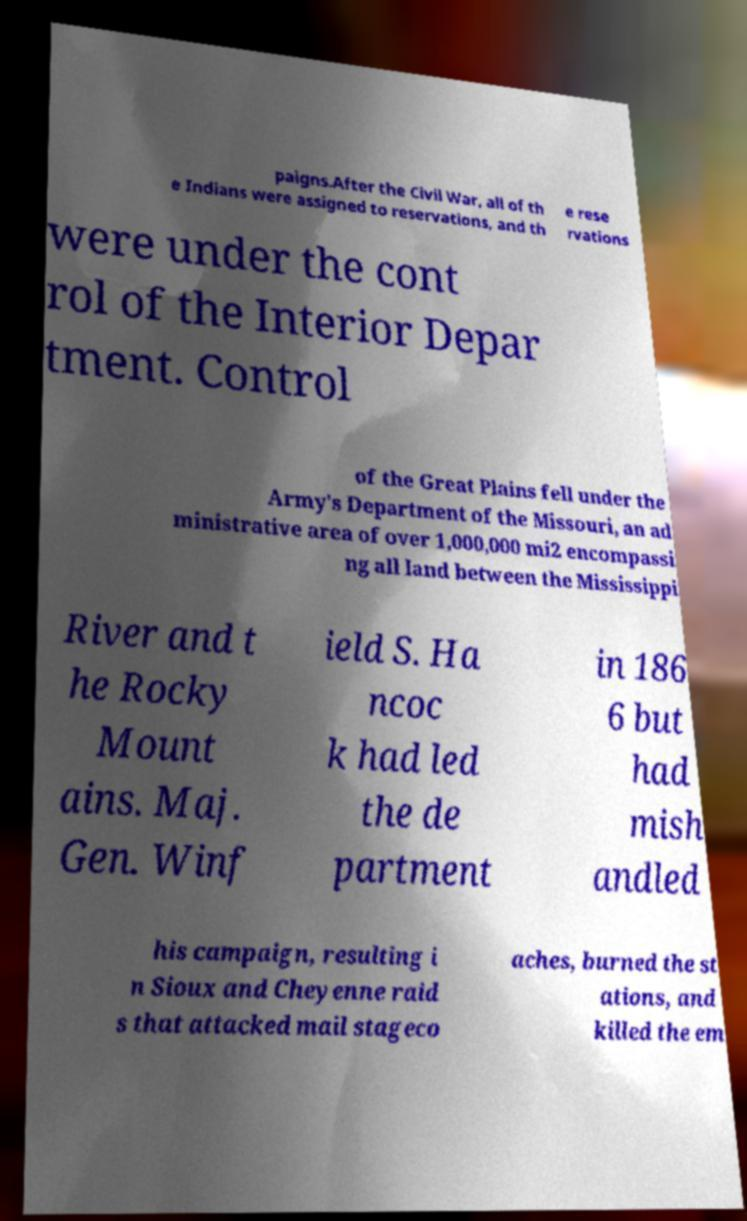There's text embedded in this image that I need extracted. Can you transcribe it verbatim? paigns.After the Civil War, all of th e Indians were assigned to reservations, and th e rese rvations were under the cont rol of the Interior Depar tment. Control of the Great Plains fell under the Army's Department of the Missouri, an ad ministrative area of over 1,000,000 mi2 encompassi ng all land between the Mississippi River and t he Rocky Mount ains. Maj. Gen. Winf ield S. Ha ncoc k had led the de partment in 186 6 but had mish andled his campaign, resulting i n Sioux and Cheyenne raid s that attacked mail stageco aches, burned the st ations, and killed the em 